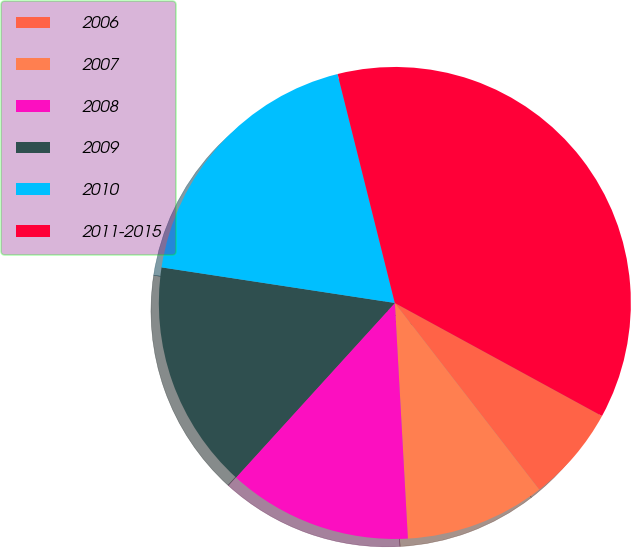Convert chart to OTSL. <chart><loc_0><loc_0><loc_500><loc_500><pie_chart><fcel>2006<fcel>2007<fcel>2008<fcel>2009<fcel>2010<fcel>2011-2015<nl><fcel>6.57%<fcel>9.6%<fcel>12.63%<fcel>15.66%<fcel>18.69%<fcel>36.85%<nl></chart> 